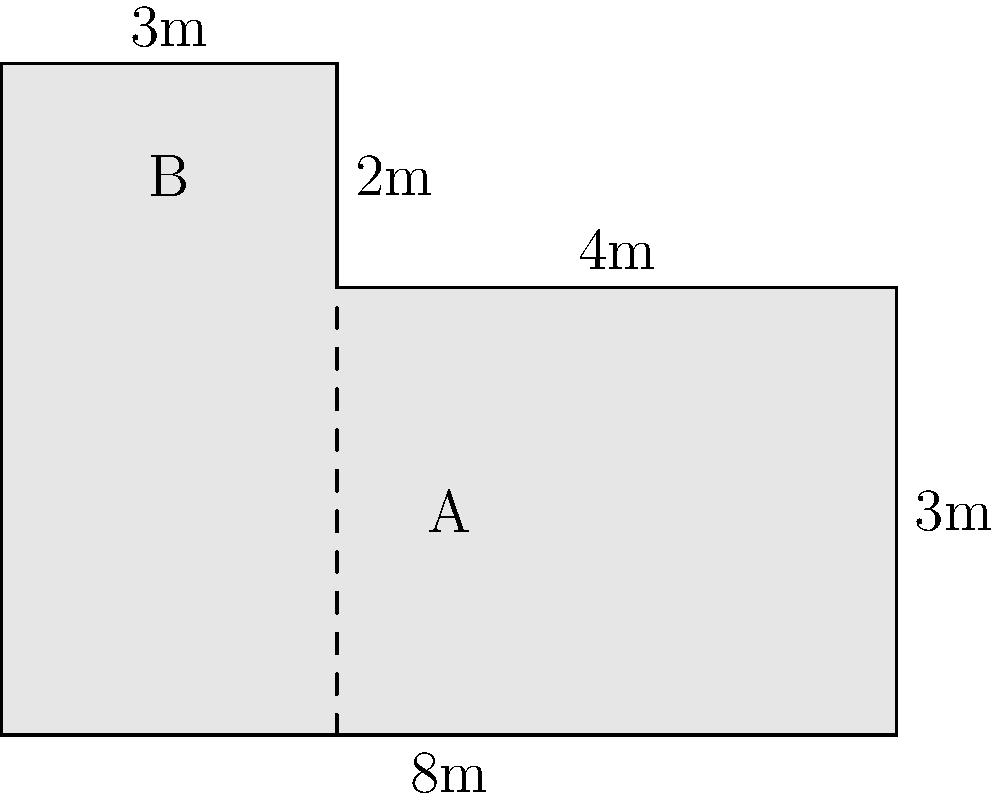A new L-shaped slot machine section is being installed on the casino floor. The section is composed of two rectangles: section A with dimensions 8m by 4m, and section B with dimensions 3m by 2m. What is the total area of this L-shaped slot machine section in square meters? To find the total area of the L-shaped slot machine section, we need to:

1. Calculate the area of rectangle A:
   $A_A = 8m \times 4m = 32m^2$

2. Calculate the area of rectangle B:
   $A_B = 3m \times 2m = 6m^2$

3. Sum the areas of both rectangles:
   $A_{total} = A_A + A_B = 32m^2 + 6m^2 = 38m^2$

Therefore, the total area of the L-shaped slot machine section is $38m^2$.
Answer: $38m^2$ 